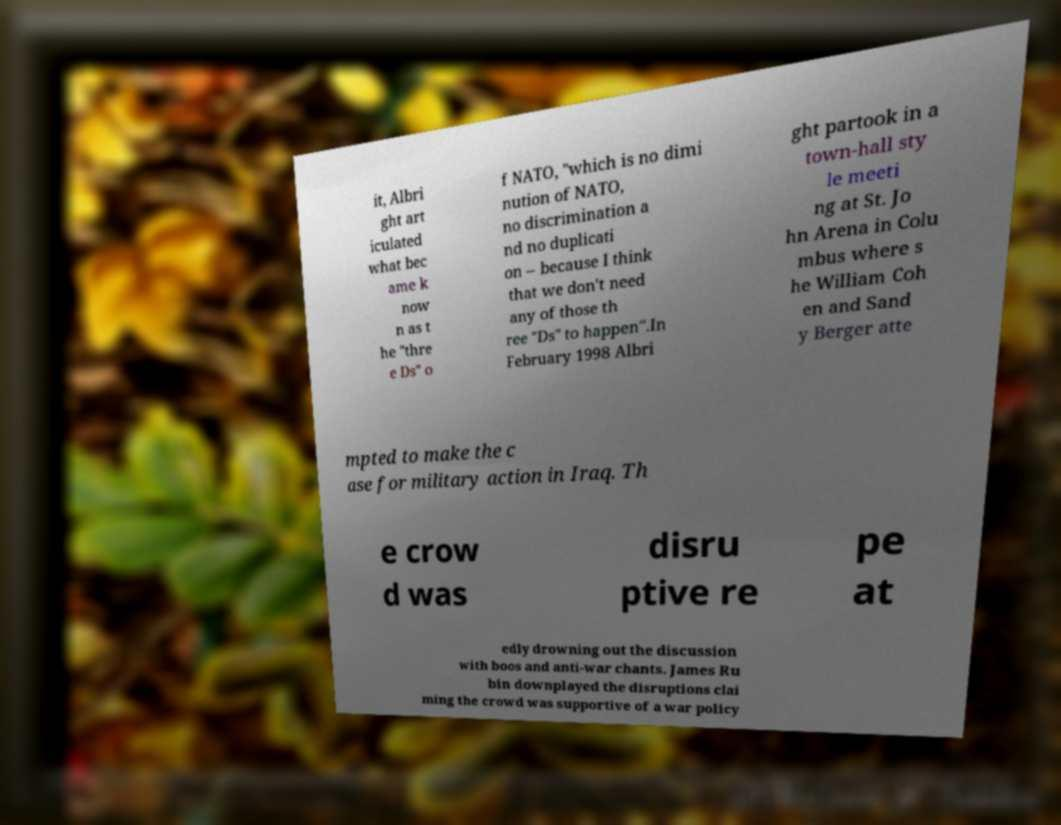Please identify and transcribe the text found in this image. it, Albri ght art iculated what bec ame k now n as t he "thre e Ds" o f NATO, "which is no dimi nution of NATO, no discrimination a nd no duplicati on – because I think that we don't need any of those th ree "Ds" to happen".In February 1998 Albri ght partook in a town-hall sty le meeti ng at St. Jo hn Arena in Colu mbus where s he William Coh en and Sand y Berger atte mpted to make the c ase for military action in Iraq. Th e crow d was disru ptive re pe at edly drowning out the discussion with boos and anti-war chants. James Ru bin downplayed the disruptions clai ming the crowd was supportive of a war policy 